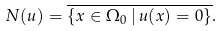<formula> <loc_0><loc_0><loc_500><loc_500>N ( u ) = \overline { \{ x \in \Omega _ { 0 } \, | \, u ( x ) = 0 \} } .</formula> 